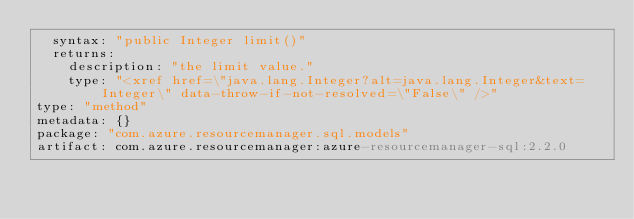Convert code to text. <code><loc_0><loc_0><loc_500><loc_500><_YAML_>  syntax: "public Integer limit()"
  returns:
    description: "the limit value."
    type: "<xref href=\"java.lang.Integer?alt=java.lang.Integer&text=Integer\" data-throw-if-not-resolved=\"False\" />"
type: "method"
metadata: {}
package: "com.azure.resourcemanager.sql.models"
artifact: com.azure.resourcemanager:azure-resourcemanager-sql:2.2.0
</code> 